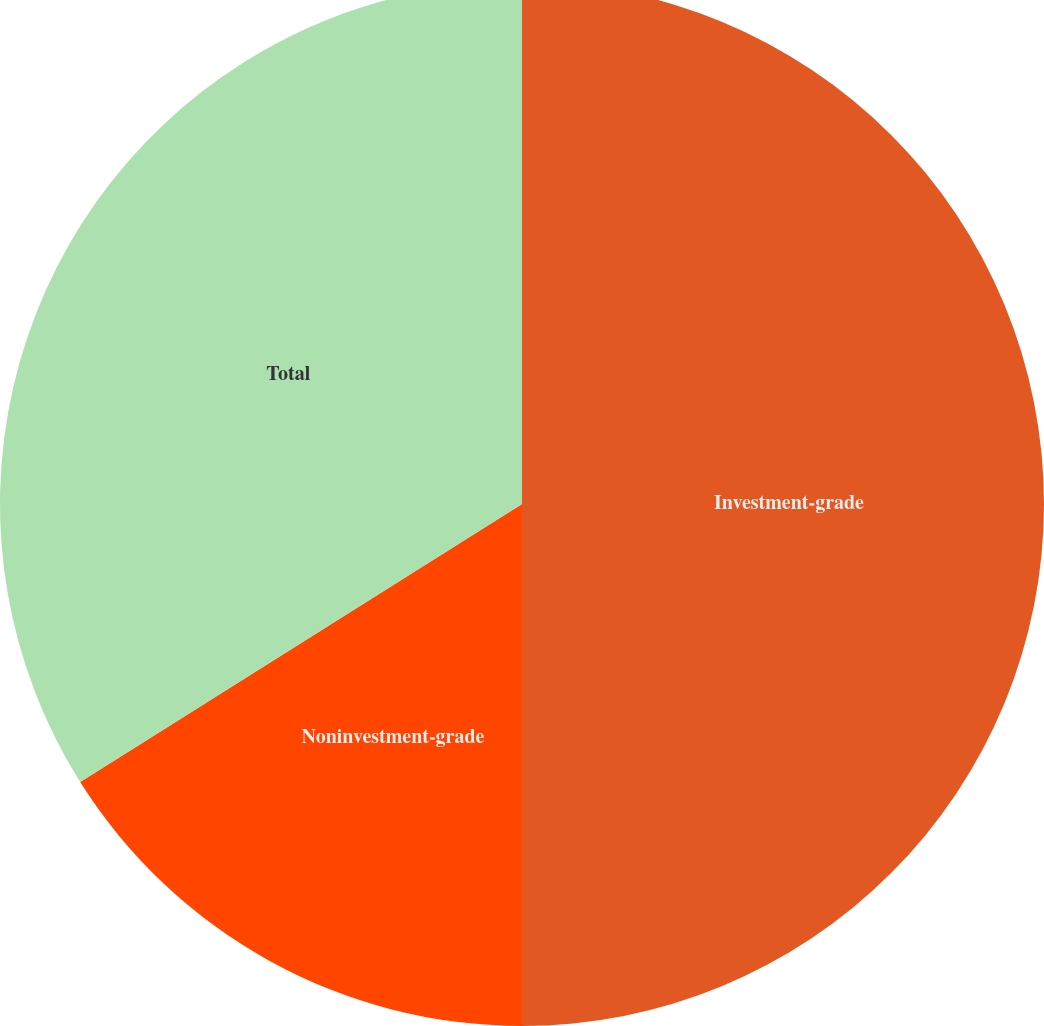<chart> <loc_0><loc_0><loc_500><loc_500><pie_chart><fcel>Investment-grade<fcel>Noninvestment-grade<fcel>Total<nl><fcel>50.0%<fcel>16.06%<fcel>33.94%<nl></chart> 